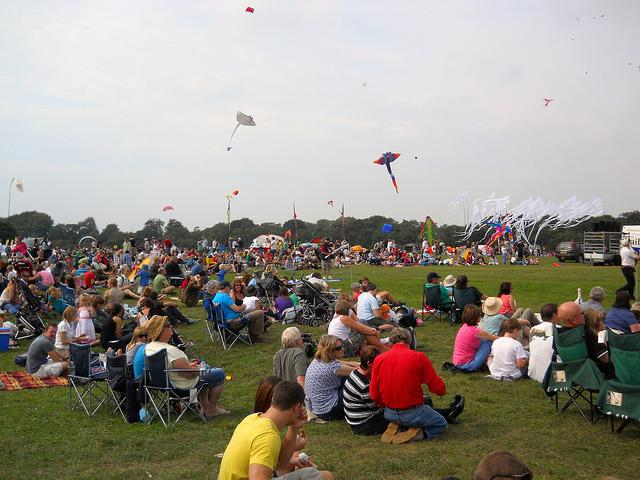What type toys unite these people today? kites 